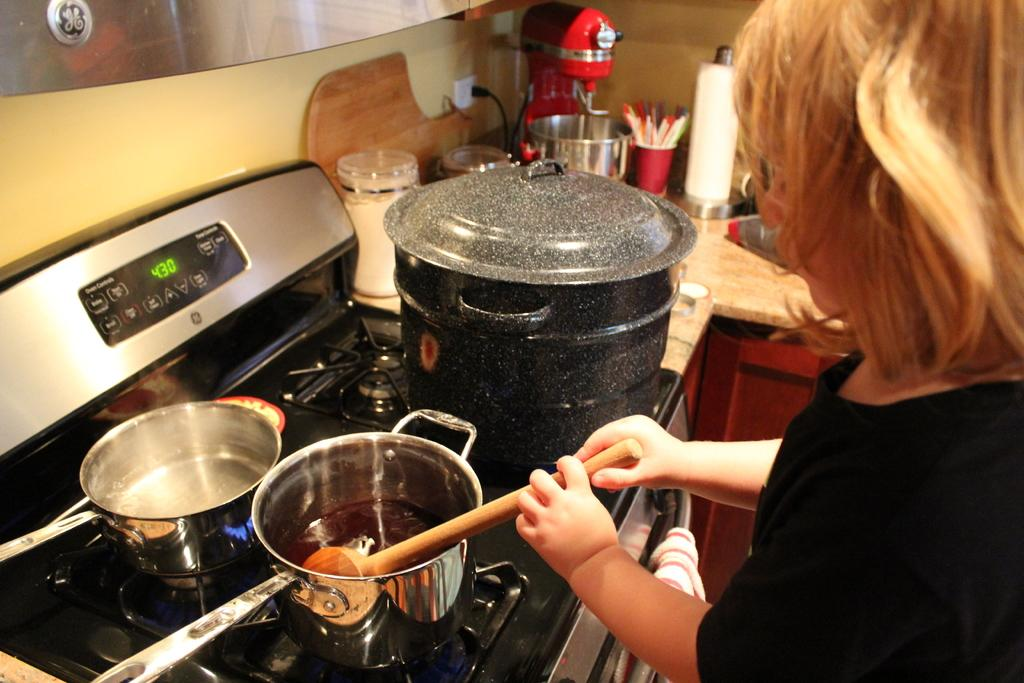<image>
Share a concise interpretation of the image provided. The digital display of an oven shows the time of 4:30. 